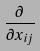<formula> <loc_0><loc_0><loc_500><loc_500>\frac { \partial } { \partial x _ { i j } }</formula> 